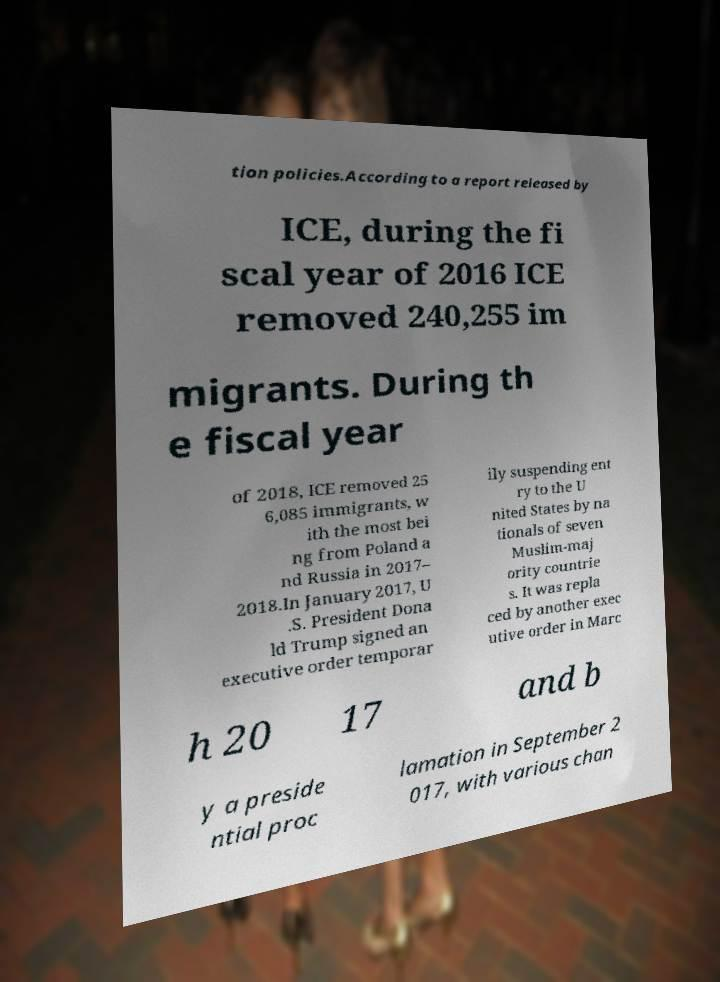I need the written content from this picture converted into text. Can you do that? tion policies.According to a report released by ICE, during the fi scal year of 2016 ICE removed 240,255 im migrants. During th e fiscal year of 2018, ICE removed 25 6,085 immigrants, w ith the most bei ng from Poland a nd Russia in 2017– 2018.In January 2017, U .S. President Dona ld Trump signed an executive order temporar ily suspending ent ry to the U nited States by na tionals of seven Muslim-maj ority countrie s. It was repla ced by another exec utive order in Marc h 20 17 and b y a preside ntial proc lamation in September 2 017, with various chan 